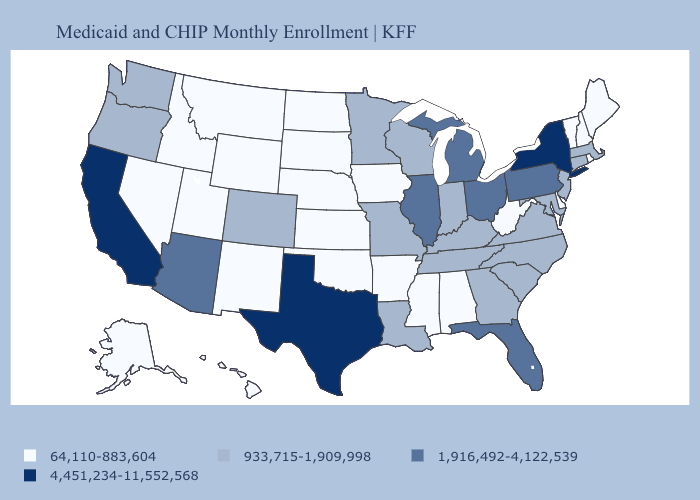Name the states that have a value in the range 1,916,492-4,122,539?
Give a very brief answer. Arizona, Florida, Illinois, Michigan, Ohio, Pennsylvania. What is the lowest value in the USA?
Keep it brief. 64,110-883,604. Does California have the highest value in the USA?
Write a very short answer. Yes. Does New Hampshire have a lower value than Washington?
Answer briefly. Yes. What is the value of Massachusetts?
Quick response, please. 933,715-1,909,998. Name the states that have a value in the range 933,715-1,909,998?
Concise answer only. Colorado, Connecticut, Georgia, Indiana, Kentucky, Louisiana, Maryland, Massachusetts, Minnesota, Missouri, New Jersey, North Carolina, Oregon, South Carolina, Tennessee, Virginia, Washington, Wisconsin. Name the states that have a value in the range 4,451,234-11,552,568?
Quick response, please. California, New York, Texas. What is the value of South Carolina?
Keep it brief. 933,715-1,909,998. What is the value of Rhode Island?
Short answer required. 64,110-883,604. Does New York have a higher value than California?
Answer briefly. No. Is the legend a continuous bar?
Short answer required. No. What is the value of Idaho?
Concise answer only. 64,110-883,604. What is the value of North Carolina?
Concise answer only. 933,715-1,909,998. Name the states that have a value in the range 4,451,234-11,552,568?
Give a very brief answer. California, New York, Texas. What is the highest value in the West ?
Short answer required. 4,451,234-11,552,568. 